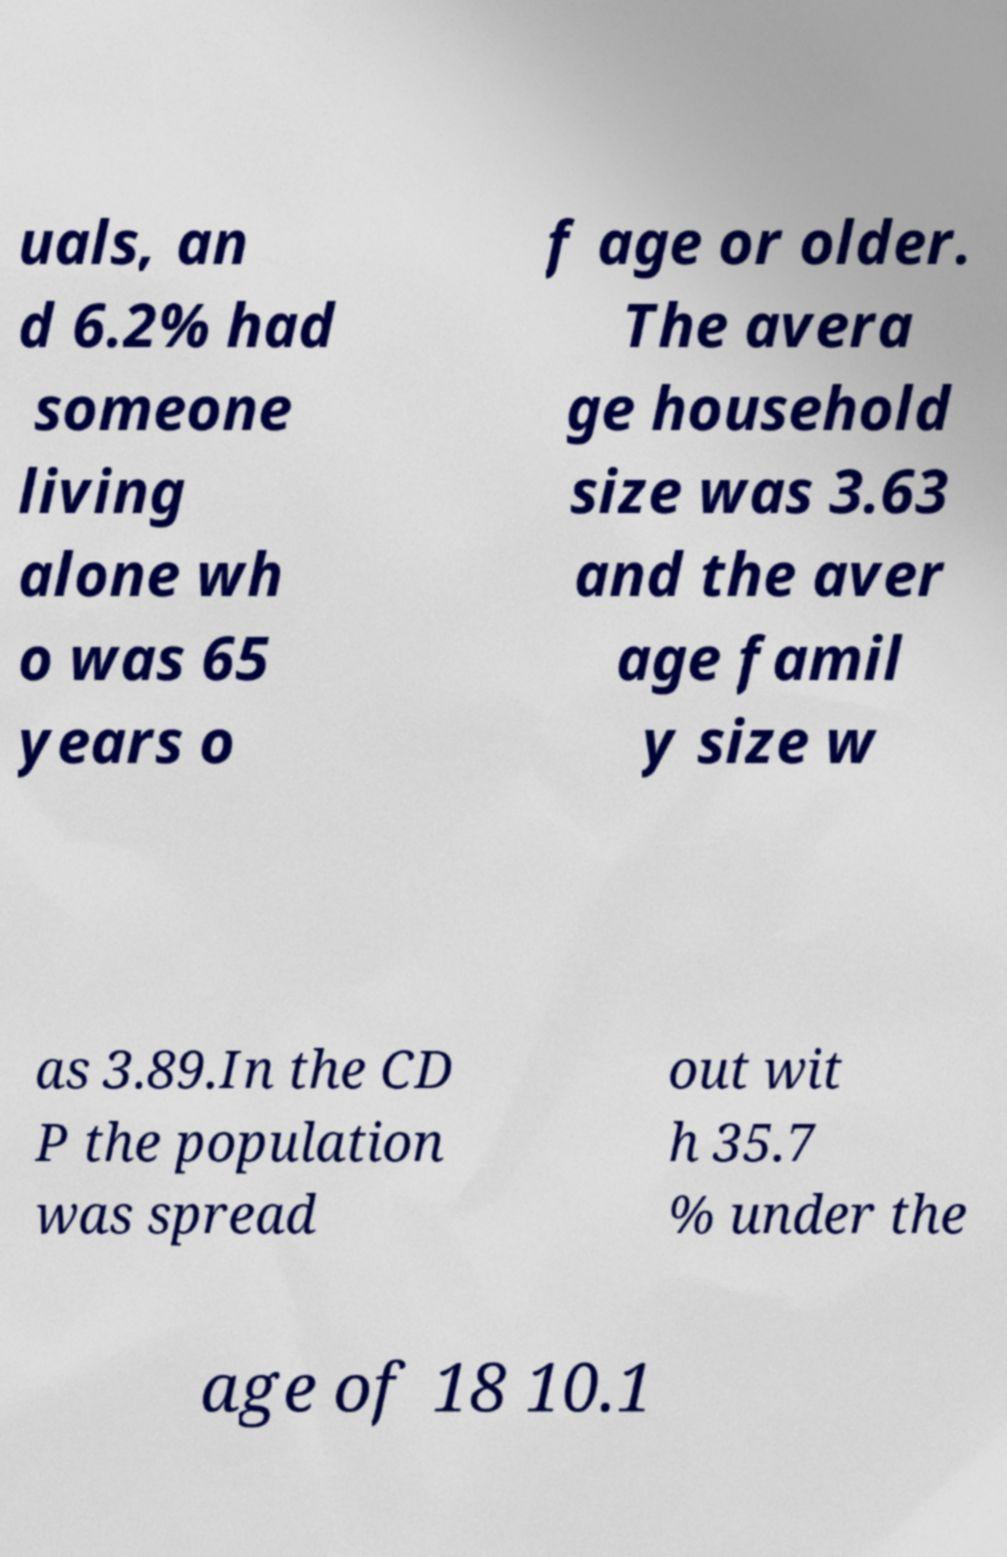Please read and relay the text visible in this image. What does it say? uals, an d 6.2% had someone living alone wh o was 65 years o f age or older. The avera ge household size was 3.63 and the aver age famil y size w as 3.89.In the CD P the population was spread out wit h 35.7 % under the age of 18 10.1 